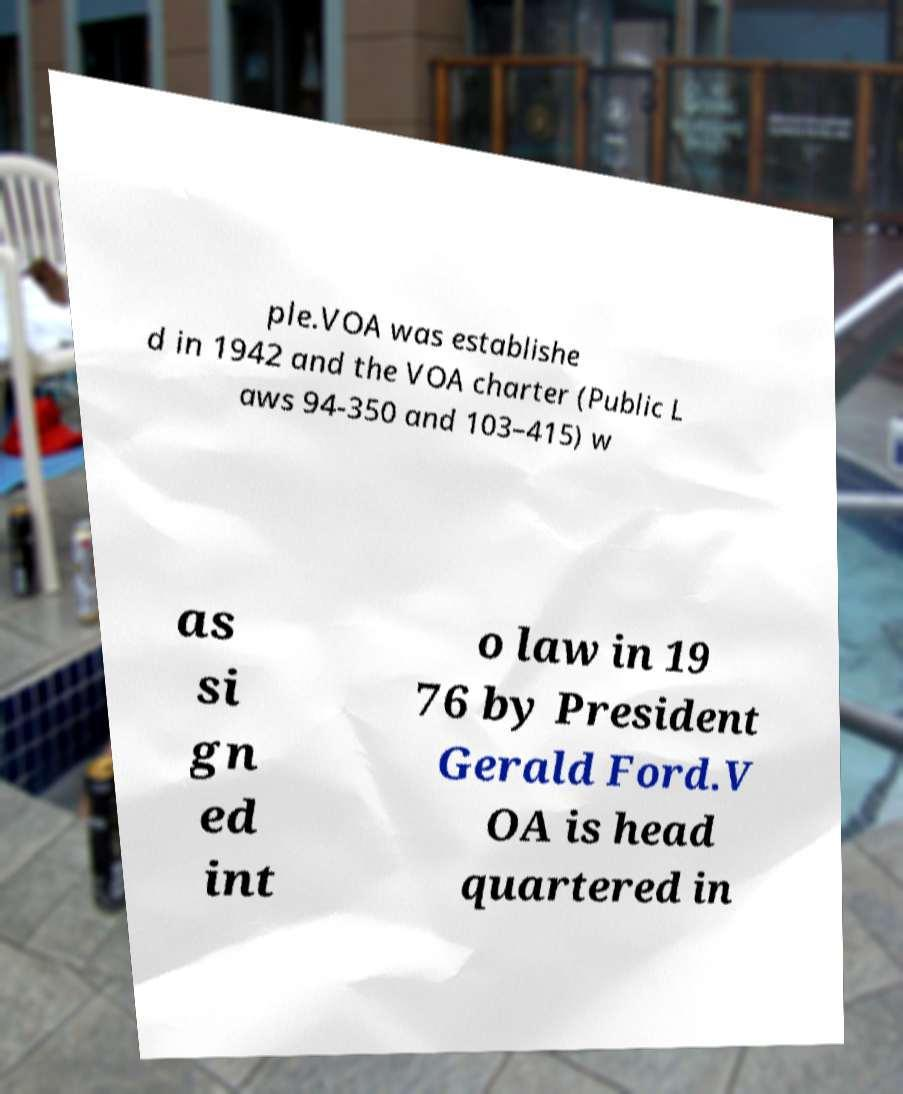There's text embedded in this image that I need extracted. Can you transcribe it verbatim? ple.VOA was establishe d in 1942 and the VOA charter (Public L aws 94-350 and 103–415) w as si gn ed int o law in 19 76 by President Gerald Ford.V OA is head quartered in 